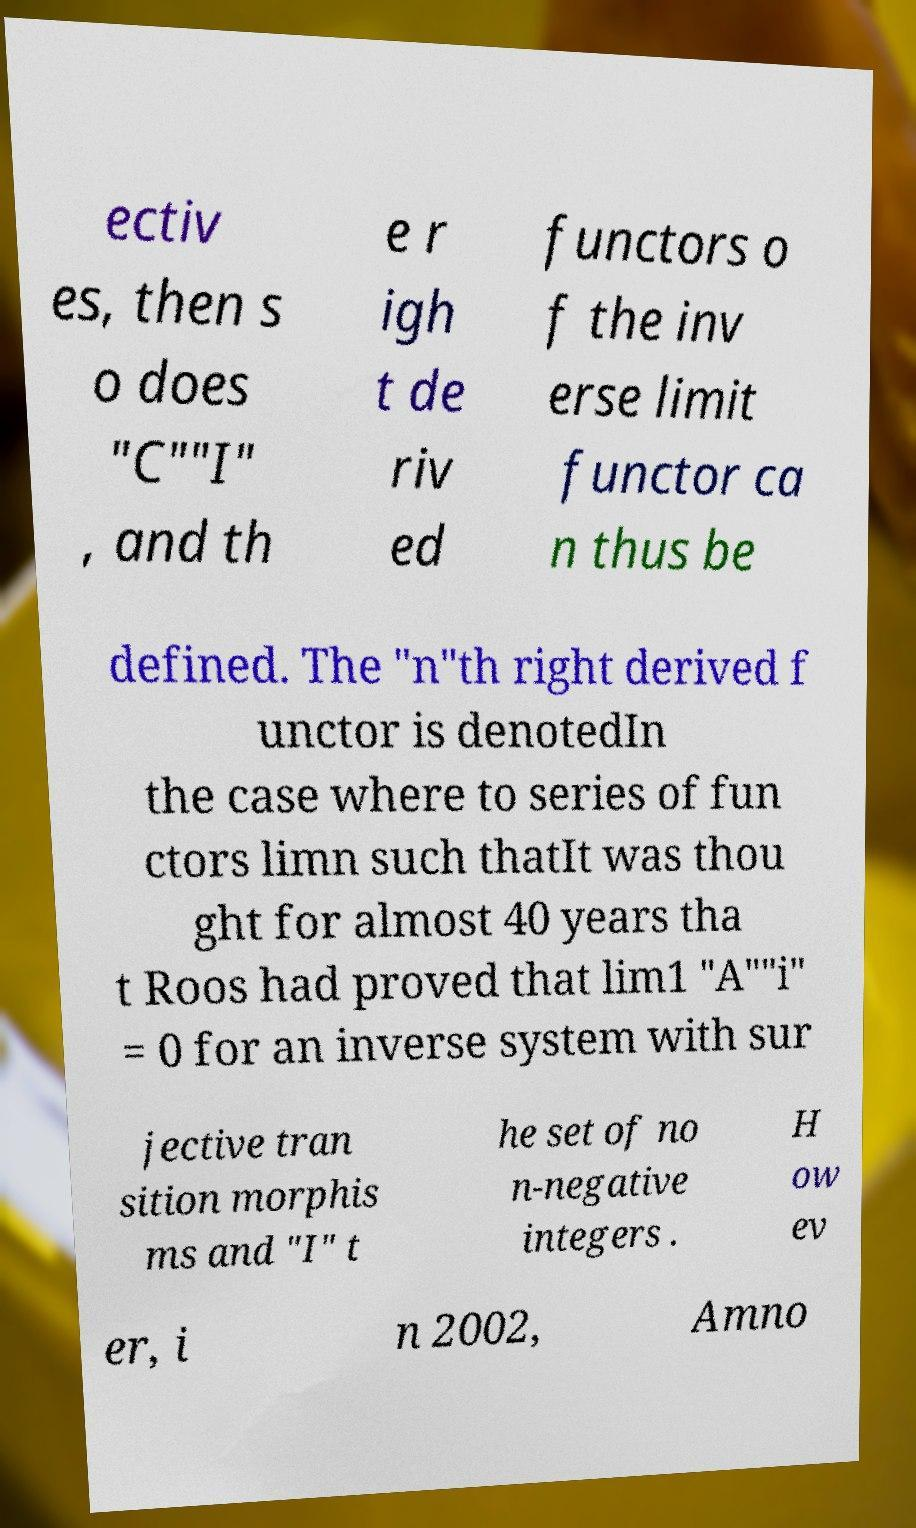There's text embedded in this image that I need extracted. Can you transcribe it verbatim? ectiv es, then s o does "C""I" , and th e r igh t de riv ed functors o f the inv erse limit functor ca n thus be defined. The "n"th right derived f unctor is denotedIn the case where to series of fun ctors limn such thatIt was thou ght for almost 40 years tha t Roos had proved that lim1 "A""i" = 0 for an inverse system with sur jective tran sition morphis ms and "I" t he set of no n-negative integers . H ow ev er, i n 2002, Amno 